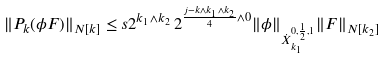Convert formula to latex. <formula><loc_0><loc_0><loc_500><loc_500>\| P _ { k } ( \phi F ) \| _ { N [ k ] } \leq s 2 ^ { k _ { 1 } \wedge k _ { 2 } } \, 2 ^ { \frac { j - k \wedge k _ { 1 } \wedge k _ { 2 } } { 4 } \wedge 0 } \| \phi \| _ { \dot { X } _ { k _ { 1 } } ^ { 0 , \frac { 1 } { 2 } , 1 } } \| F \| _ { N [ k _ { 2 } ] }</formula> 